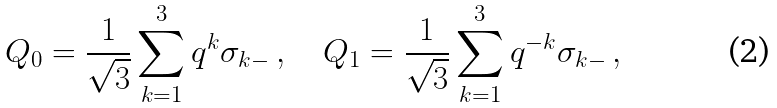<formula> <loc_0><loc_0><loc_500><loc_500>Q _ { 0 } = \frac { 1 } { \sqrt { 3 } } \sum _ { k = 1 } ^ { 3 } q ^ { k } \sigma _ { k - } \, , \quad Q _ { 1 } = \frac { 1 } { \sqrt { 3 } } \sum _ { k = 1 } ^ { 3 } q ^ { - k } \sigma _ { k - } \, ,</formula> 